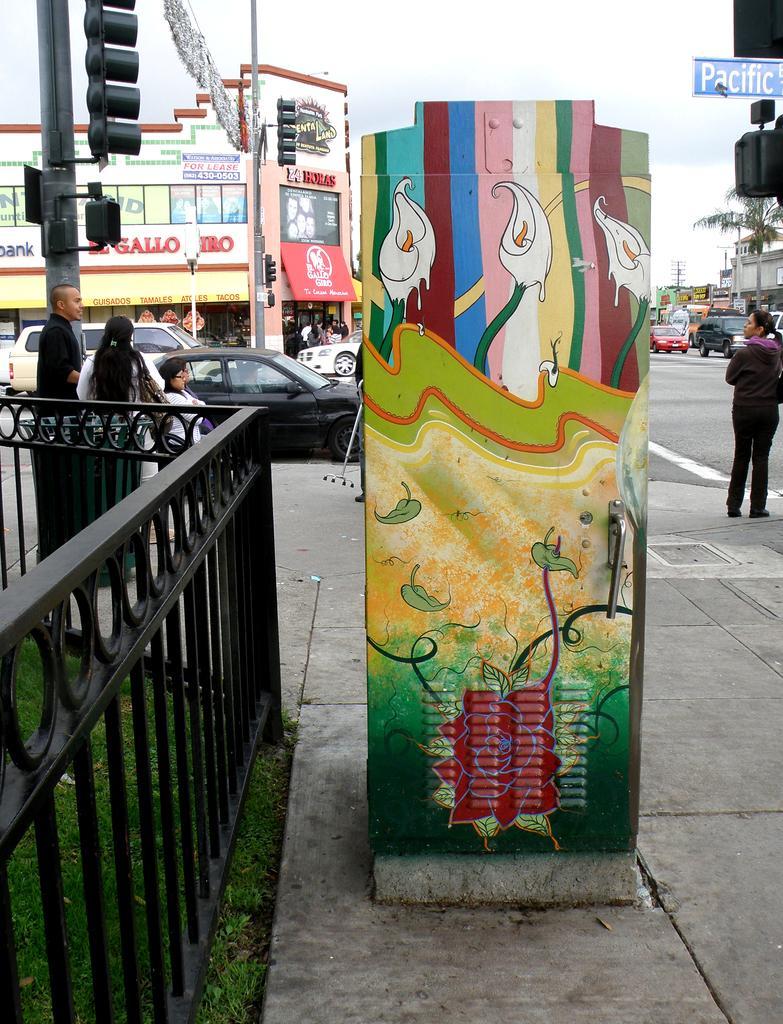In one or two sentences, can you explain what this image depicts? In the picture I can see fence, people and cars on the road. I can also see traffic lights, banners which has something written on it and some other object. In the background I can see buildings, a tree, the sky and some other objects. 